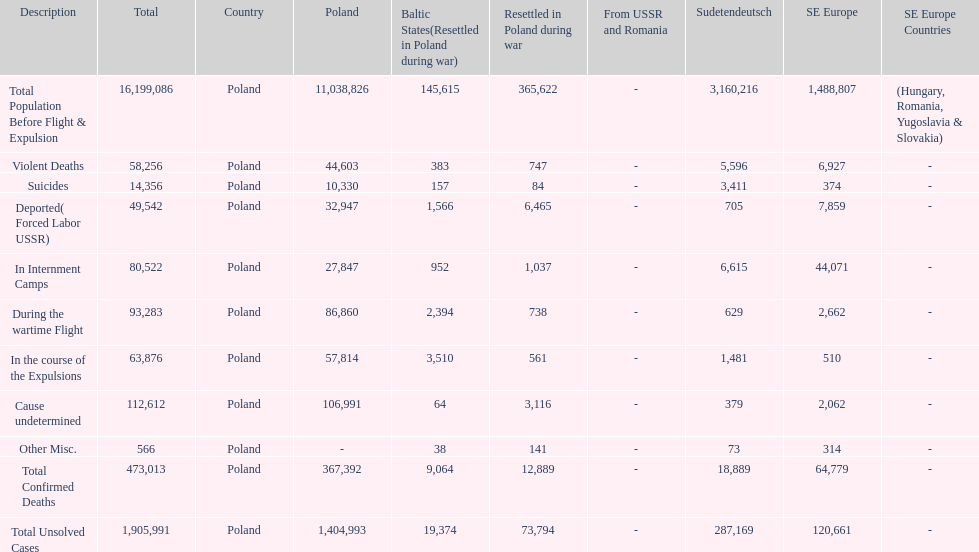Were there more cause undetermined or miscellaneous deaths in the baltic states? Cause undetermined. 